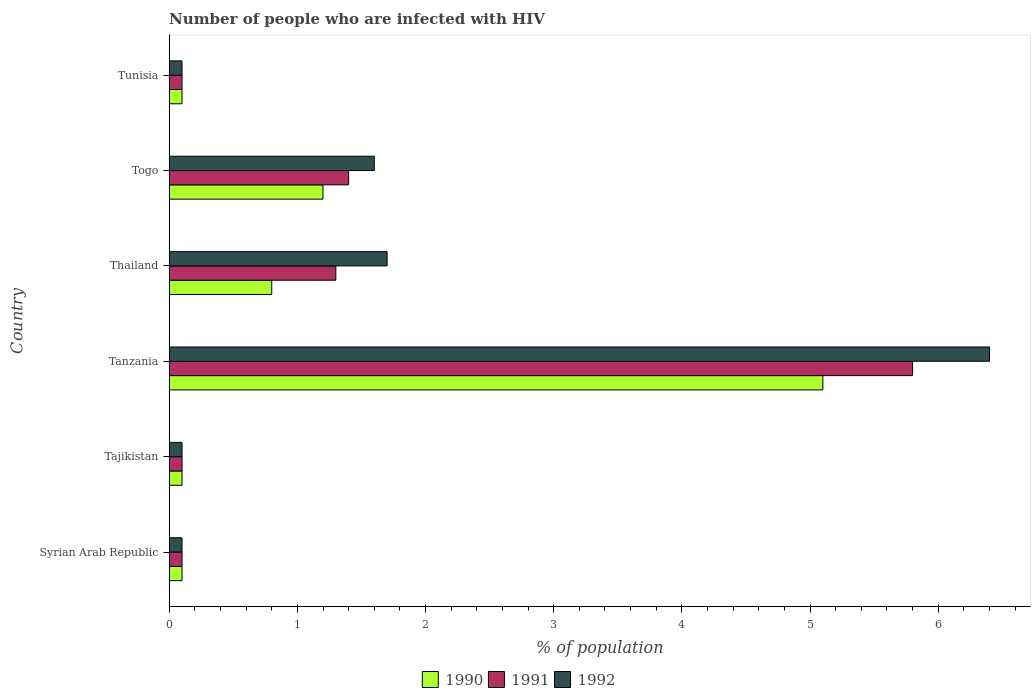How many groups of bars are there?
Offer a very short reply. 6. Are the number of bars per tick equal to the number of legend labels?
Provide a succinct answer. Yes. How many bars are there on the 1st tick from the top?
Give a very brief answer. 3. How many bars are there on the 4th tick from the bottom?
Keep it short and to the point. 3. What is the label of the 3rd group of bars from the top?
Offer a terse response. Thailand. Across all countries, what is the minimum percentage of HIV infected population in in 1991?
Provide a short and direct response. 0.1. In which country was the percentage of HIV infected population in in 1990 maximum?
Make the answer very short. Tanzania. In which country was the percentage of HIV infected population in in 1990 minimum?
Your answer should be compact. Syrian Arab Republic. What is the total percentage of HIV infected population in in 1991 in the graph?
Your answer should be very brief. 8.8. What is the difference between the percentage of HIV infected population in in 1992 in Syrian Arab Republic and that in Thailand?
Your answer should be compact. -1.6. What is the difference between the percentage of HIV infected population in in 1991 in Thailand and the percentage of HIV infected population in in 1990 in Tajikistan?
Give a very brief answer. 1.2. What is the average percentage of HIV infected population in in 1990 per country?
Your answer should be compact. 1.23. What is the ratio of the percentage of HIV infected population in in 1991 in Tajikistan to that in Thailand?
Keep it short and to the point. 0.08. What is the difference between the highest and the lowest percentage of HIV infected population in in 1992?
Ensure brevity in your answer.  6.3. Is the sum of the percentage of HIV infected population in in 1991 in Tajikistan and Tanzania greater than the maximum percentage of HIV infected population in in 1992 across all countries?
Your answer should be very brief. No. What does the 2nd bar from the bottom in Tajikistan represents?
Your answer should be compact. 1991. Is it the case that in every country, the sum of the percentage of HIV infected population in in 1992 and percentage of HIV infected population in in 1990 is greater than the percentage of HIV infected population in in 1991?
Offer a very short reply. Yes. How many bars are there?
Give a very brief answer. 18. Are all the bars in the graph horizontal?
Offer a very short reply. Yes. What is the difference between two consecutive major ticks on the X-axis?
Your answer should be very brief. 1. Does the graph contain grids?
Make the answer very short. No. Where does the legend appear in the graph?
Provide a succinct answer. Bottom center. How many legend labels are there?
Your answer should be very brief. 3. What is the title of the graph?
Provide a succinct answer. Number of people who are infected with HIV. What is the label or title of the X-axis?
Give a very brief answer. % of population. What is the label or title of the Y-axis?
Your answer should be very brief. Country. What is the % of population of 1991 in Syrian Arab Republic?
Your answer should be compact. 0.1. What is the % of population in 1992 in Syrian Arab Republic?
Give a very brief answer. 0.1. What is the % of population in 1991 in Tajikistan?
Your response must be concise. 0.1. What is the % of population of 1990 in Tanzania?
Provide a succinct answer. 5.1. What is the % of population of 1991 in Tanzania?
Make the answer very short. 5.8. What is the % of population of 1992 in Tanzania?
Your answer should be very brief. 6.4. What is the % of population in 1990 in Thailand?
Your response must be concise. 0.8. What is the % of population of 1991 in Togo?
Ensure brevity in your answer.  1.4. What is the % of population of 1990 in Tunisia?
Provide a short and direct response. 0.1. What is the % of population of 1991 in Tunisia?
Keep it short and to the point. 0.1. What is the % of population of 1992 in Tunisia?
Keep it short and to the point. 0.1. Across all countries, what is the maximum % of population in 1991?
Give a very brief answer. 5.8. Across all countries, what is the minimum % of population of 1990?
Your answer should be compact. 0.1. Across all countries, what is the minimum % of population of 1991?
Offer a terse response. 0.1. What is the total % of population in 1991 in the graph?
Offer a very short reply. 8.8. What is the total % of population of 1992 in the graph?
Your response must be concise. 10. What is the difference between the % of population of 1990 in Syrian Arab Republic and that in Tajikistan?
Make the answer very short. 0. What is the difference between the % of population of 1992 in Syrian Arab Republic and that in Tanzania?
Your answer should be very brief. -6.3. What is the difference between the % of population of 1990 in Syrian Arab Republic and that in Thailand?
Offer a terse response. -0.7. What is the difference between the % of population of 1991 in Syrian Arab Republic and that in Thailand?
Your response must be concise. -1.2. What is the difference between the % of population in 1992 in Syrian Arab Republic and that in Togo?
Provide a succinct answer. -1.5. What is the difference between the % of population of 1990 in Syrian Arab Republic and that in Tunisia?
Give a very brief answer. 0. What is the difference between the % of population in 1991 in Syrian Arab Republic and that in Tunisia?
Ensure brevity in your answer.  0. What is the difference between the % of population of 1990 in Tajikistan and that in Togo?
Offer a very short reply. -1.1. What is the difference between the % of population in 1992 in Tajikistan and that in Togo?
Ensure brevity in your answer.  -1.5. What is the difference between the % of population in 1990 in Tajikistan and that in Tunisia?
Offer a very short reply. 0. What is the difference between the % of population of 1991 in Tajikistan and that in Tunisia?
Ensure brevity in your answer.  0. What is the difference between the % of population in 1992 in Tajikistan and that in Tunisia?
Provide a short and direct response. 0. What is the difference between the % of population in 1991 in Tanzania and that in Thailand?
Provide a short and direct response. 4.5. What is the difference between the % of population in 1992 in Tanzania and that in Thailand?
Ensure brevity in your answer.  4.7. What is the difference between the % of population in 1992 in Tanzania and that in Togo?
Provide a succinct answer. 4.8. What is the difference between the % of population of 1990 in Thailand and that in Togo?
Provide a succinct answer. -0.4. What is the difference between the % of population in 1991 in Thailand and that in Togo?
Give a very brief answer. -0.1. What is the difference between the % of population of 1992 in Thailand and that in Togo?
Your response must be concise. 0.1. What is the difference between the % of population in 1991 in Thailand and that in Tunisia?
Provide a short and direct response. 1.2. What is the difference between the % of population of 1992 in Thailand and that in Tunisia?
Provide a succinct answer. 1.6. What is the difference between the % of population in 1990 in Togo and that in Tunisia?
Offer a terse response. 1.1. What is the difference between the % of population in 1991 in Togo and that in Tunisia?
Provide a succinct answer. 1.3. What is the difference between the % of population of 1992 in Togo and that in Tunisia?
Ensure brevity in your answer.  1.5. What is the difference between the % of population in 1990 in Syrian Arab Republic and the % of population in 1991 in Tajikistan?
Provide a succinct answer. 0. What is the difference between the % of population in 1990 in Syrian Arab Republic and the % of population in 1992 in Tanzania?
Your answer should be compact. -6.3. What is the difference between the % of population of 1990 in Syrian Arab Republic and the % of population of 1991 in Togo?
Keep it short and to the point. -1.3. What is the difference between the % of population in 1990 in Syrian Arab Republic and the % of population in 1992 in Togo?
Ensure brevity in your answer.  -1.5. What is the difference between the % of population in 1991 in Syrian Arab Republic and the % of population in 1992 in Tunisia?
Keep it short and to the point. 0. What is the difference between the % of population in 1990 in Tajikistan and the % of population in 1991 in Tanzania?
Offer a very short reply. -5.7. What is the difference between the % of population in 1990 in Tajikistan and the % of population in 1992 in Tanzania?
Give a very brief answer. -6.3. What is the difference between the % of population in 1990 in Tajikistan and the % of population in 1991 in Thailand?
Your response must be concise. -1.2. What is the difference between the % of population in 1990 in Tajikistan and the % of population in 1992 in Thailand?
Offer a terse response. -1.6. What is the difference between the % of population in 1991 in Tajikistan and the % of population in 1992 in Thailand?
Ensure brevity in your answer.  -1.6. What is the difference between the % of population of 1990 in Tajikistan and the % of population of 1992 in Togo?
Make the answer very short. -1.5. What is the difference between the % of population of 1990 in Tajikistan and the % of population of 1991 in Tunisia?
Offer a very short reply. 0. What is the difference between the % of population of 1990 in Tanzania and the % of population of 1992 in Thailand?
Ensure brevity in your answer.  3.4. What is the difference between the % of population in 1990 in Tanzania and the % of population in 1991 in Togo?
Provide a succinct answer. 3.7. What is the difference between the % of population in 1990 in Tanzania and the % of population in 1992 in Togo?
Your answer should be compact. 3.5. What is the difference between the % of population in 1991 in Tanzania and the % of population in 1992 in Togo?
Offer a terse response. 4.2. What is the difference between the % of population of 1990 in Tanzania and the % of population of 1991 in Tunisia?
Your answer should be compact. 5. What is the difference between the % of population in 1991 in Tanzania and the % of population in 1992 in Tunisia?
Ensure brevity in your answer.  5.7. What is the difference between the % of population of 1990 in Thailand and the % of population of 1992 in Togo?
Your answer should be very brief. -0.8. What is the difference between the % of population in 1991 in Thailand and the % of population in 1992 in Togo?
Make the answer very short. -0.3. What is the difference between the % of population in 1990 in Togo and the % of population in 1991 in Tunisia?
Give a very brief answer. 1.1. What is the difference between the % of population of 1990 in Togo and the % of population of 1992 in Tunisia?
Give a very brief answer. 1.1. What is the difference between the % of population of 1991 in Togo and the % of population of 1992 in Tunisia?
Your answer should be compact. 1.3. What is the average % of population of 1990 per country?
Your answer should be very brief. 1.23. What is the average % of population of 1991 per country?
Keep it short and to the point. 1.47. What is the average % of population of 1992 per country?
Provide a succinct answer. 1.67. What is the difference between the % of population of 1990 and % of population of 1991 in Syrian Arab Republic?
Offer a terse response. 0. What is the difference between the % of population of 1991 and % of population of 1992 in Syrian Arab Republic?
Provide a succinct answer. 0. What is the difference between the % of population in 1990 and % of population in 1991 in Tajikistan?
Keep it short and to the point. 0. What is the difference between the % of population in 1990 and % of population in 1992 in Tajikistan?
Keep it short and to the point. 0. What is the difference between the % of population in 1990 and % of population in 1992 in Tanzania?
Keep it short and to the point. -1.3. What is the difference between the % of population of 1991 and % of population of 1992 in Thailand?
Give a very brief answer. -0.4. What is the difference between the % of population in 1990 and % of population in 1991 in Togo?
Make the answer very short. -0.2. What is the difference between the % of population of 1991 and % of population of 1992 in Togo?
Keep it short and to the point. -0.2. What is the difference between the % of population of 1990 and % of population of 1991 in Tunisia?
Keep it short and to the point. 0. What is the ratio of the % of population of 1991 in Syrian Arab Republic to that in Tajikistan?
Make the answer very short. 1. What is the ratio of the % of population of 1992 in Syrian Arab Republic to that in Tajikistan?
Make the answer very short. 1. What is the ratio of the % of population of 1990 in Syrian Arab Republic to that in Tanzania?
Keep it short and to the point. 0.02. What is the ratio of the % of population in 1991 in Syrian Arab Republic to that in Tanzania?
Provide a short and direct response. 0.02. What is the ratio of the % of population in 1992 in Syrian Arab Republic to that in Tanzania?
Your response must be concise. 0.02. What is the ratio of the % of population in 1990 in Syrian Arab Republic to that in Thailand?
Your response must be concise. 0.12. What is the ratio of the % of population in 1991 in Syrian Arab Republic to that in Thailand?
Provide a succinct answer. 0.08. What is the ratio of the % of population of 1992 in Syrian Arab Republic to that in Thailand?
Make the answer very short. 0.06. What is the ratio of the % of population of 1990 in Syrian Arab Republic to that in Togo?
Ensure brevity in your answer.  0.08. What is the ratio of the % of population in 1991 in Syrian Arab Republic to that in Togo?
Offer a terse response. 0.07. What is the ratio of the % of population of 1992 in Syrian Arab Republic to that in Togo?
Give a very brief answer. 0.06. What is the ratio of the % of population in 1990 in Syrian Arab Republic to that in Tunisia?
Your answer should be very brief. 1. What is the ratio of the % of population in 1992 in Syrian Arab Republic to that in Tunisia?
Keep it short and to the point. 1. What is the ratio of the % of population of 1990 in Tajikistan to that in Tanzania?
Provide a succinct answer. 0.02. What is the ratio of the % of population in 1991 in Tajikistan to that in Tanzania?
Your answer should be compact. 0.02. What is the ratio of the % of population in 1992 in Tajikistan to that in Tanzania?
Give a very brief answer. 0.02. What is the ratio of the % of population of 1991 in Tajikistan to that in Thailand?
Offer a very short reply. 0.08. What is the ratio of the % of population of 1992 in Tajikistan to that in Thailand?
Provide a short and direct response. 0.06. What is the ratio of the % of population of 1990 in Tajikistan to that in Togo?
Provide a succinct answer. 0.08. What is the ratio of the % of population of 1991 in Tajikistan to that in Togo?
Offer a terse response. 0.07. What is the ratio of the % of population in 1992 in Tajikistan to that in Togo?
Give a very brief answer. 0.06. What is the ratio of the % of population of 1990 in Tajikistan to that in Tunisia?
Give a very brief answer. 1. What is the ratio of the % of population of 1991 in Tajikistan to that in Tunisia?
Make the answer very short. 1. What is the ratio of the % of population of 1992 in Tajikistan to that in Tunisia?
Your answer should be compact. 1. What is the ratio of the % of population of 1990 in Tanzania to that in Thailand?
Make the answer very short. 6.38. What is the ratio of the % of population of 1991 in Tanzania to that in Thailand?
Provide a succinct answer. 4.46. What is the ratio of the % of population of 1992 in Tanzania to that in Thailand?
Make the answer very short. 3.76. What is the ratio of the % of population in 1990 in Tanzania to that in Togo?
Your answer should be very brief. 4.25. What is the ratio of the % of population in 1991 in Tanzania to that in Togo?
Provide a succinct answer. 4.14. What is the ratio of the % of population in 1992 in Tanzania to that in Togo?
Your answer should be compact. 4. What is the ratio of the % of population of 1990 in Tanzania to that in Tunisia?
Your answer should be very brief. 51. What is the ratio of the % of population of 1991 in Tanzania to that in Tunisia?
Ensure brevity in your answer.  58. What is the ratio of the % of population of 1991 in Thailand to that in Togo?
Offer a terse response. 0.93. What is the ratio of the % of population of 1992 in Thailand to that in Togo?
Give a very brief answer. 1.06. What is the ratio of the % of population of 1990 in Thailand to that in Tunisia?
Give a very brief answer. 8. What is the ratio of the % of population of 1992 in Thailand to that in Tunisia?
Keep it short and to the point. 17. What is the ratio of the % of population of 1991 in Togo to that in Tunisia?
Offer a very short reply. 14. What is the ratio of the % of population in 1992 in Togo to that in Tunisia?
Your response must be concise. 16. What is the difference between the highest and the second highest % of population of 1990?
Offer a terse response. 3.9. What is the difference between the highest and the second highest % of population of 1992?
Make the answer very short. 4.7. What is the difference between the highest and the lowest % of population in 1992?
Offer a terse response. 6.3. 